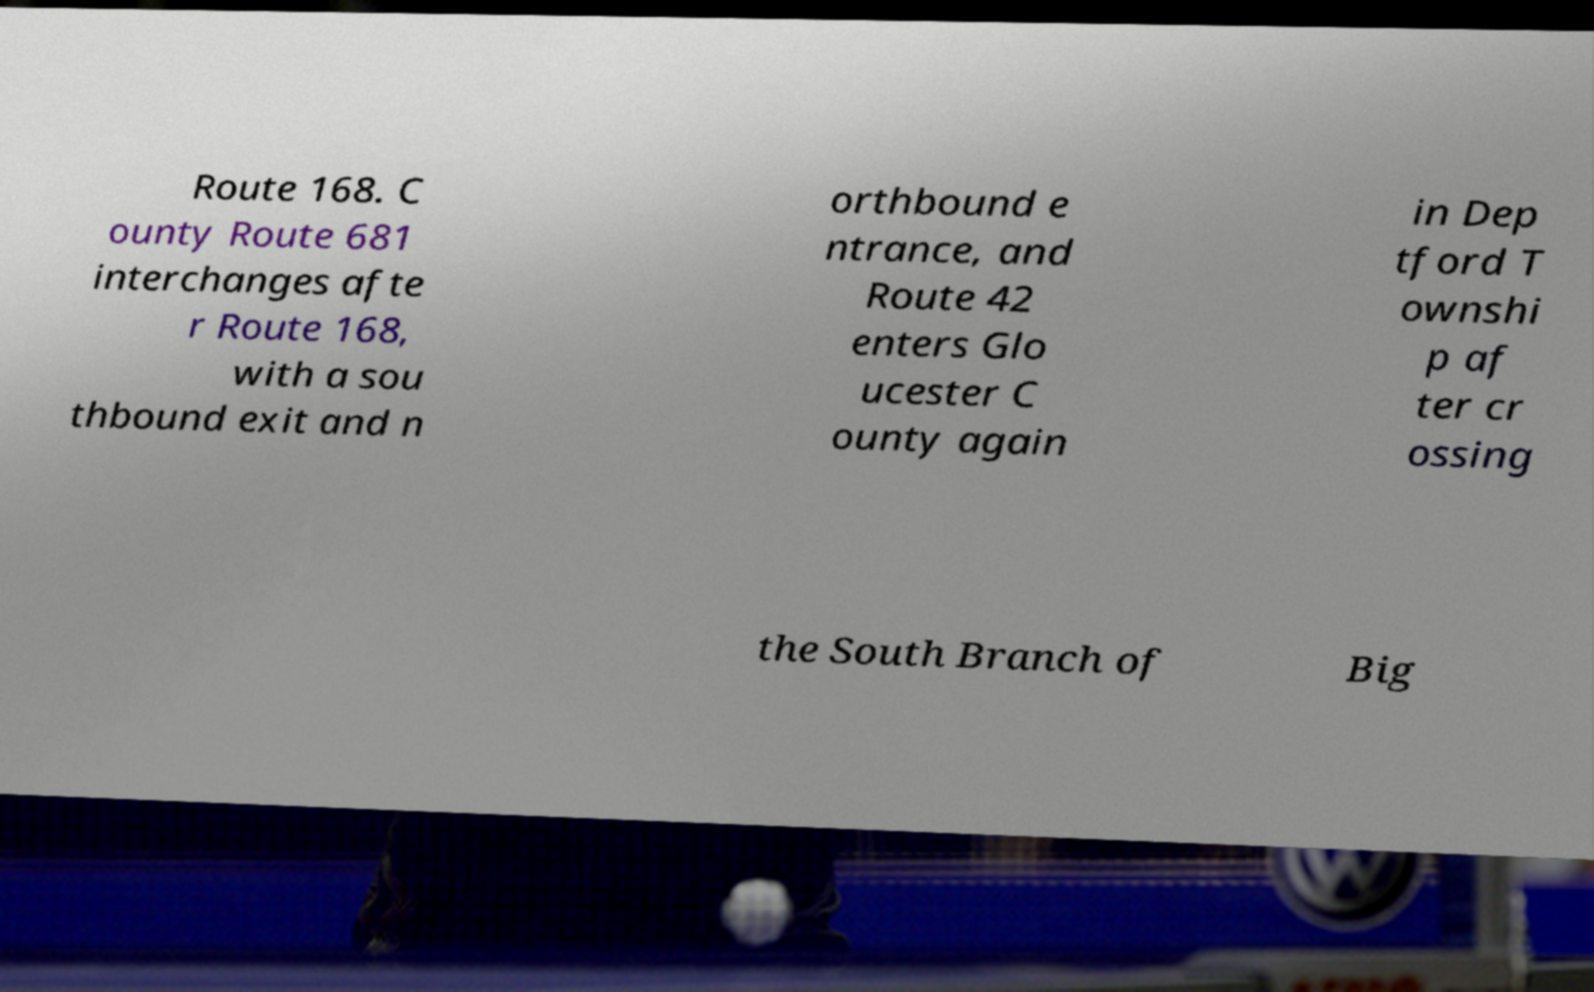For documentation purposes, I need the text within this image transcribed. Could you provide that? Route 168. C ounty Route 681 interchanges afte r Route 168, with a sou thbound exit and n orthbound e ntrance, and Route 42 enters Glo ucester C ounty again in Dep tford T ownshi p af ter cr ossing the South Branch of Big 